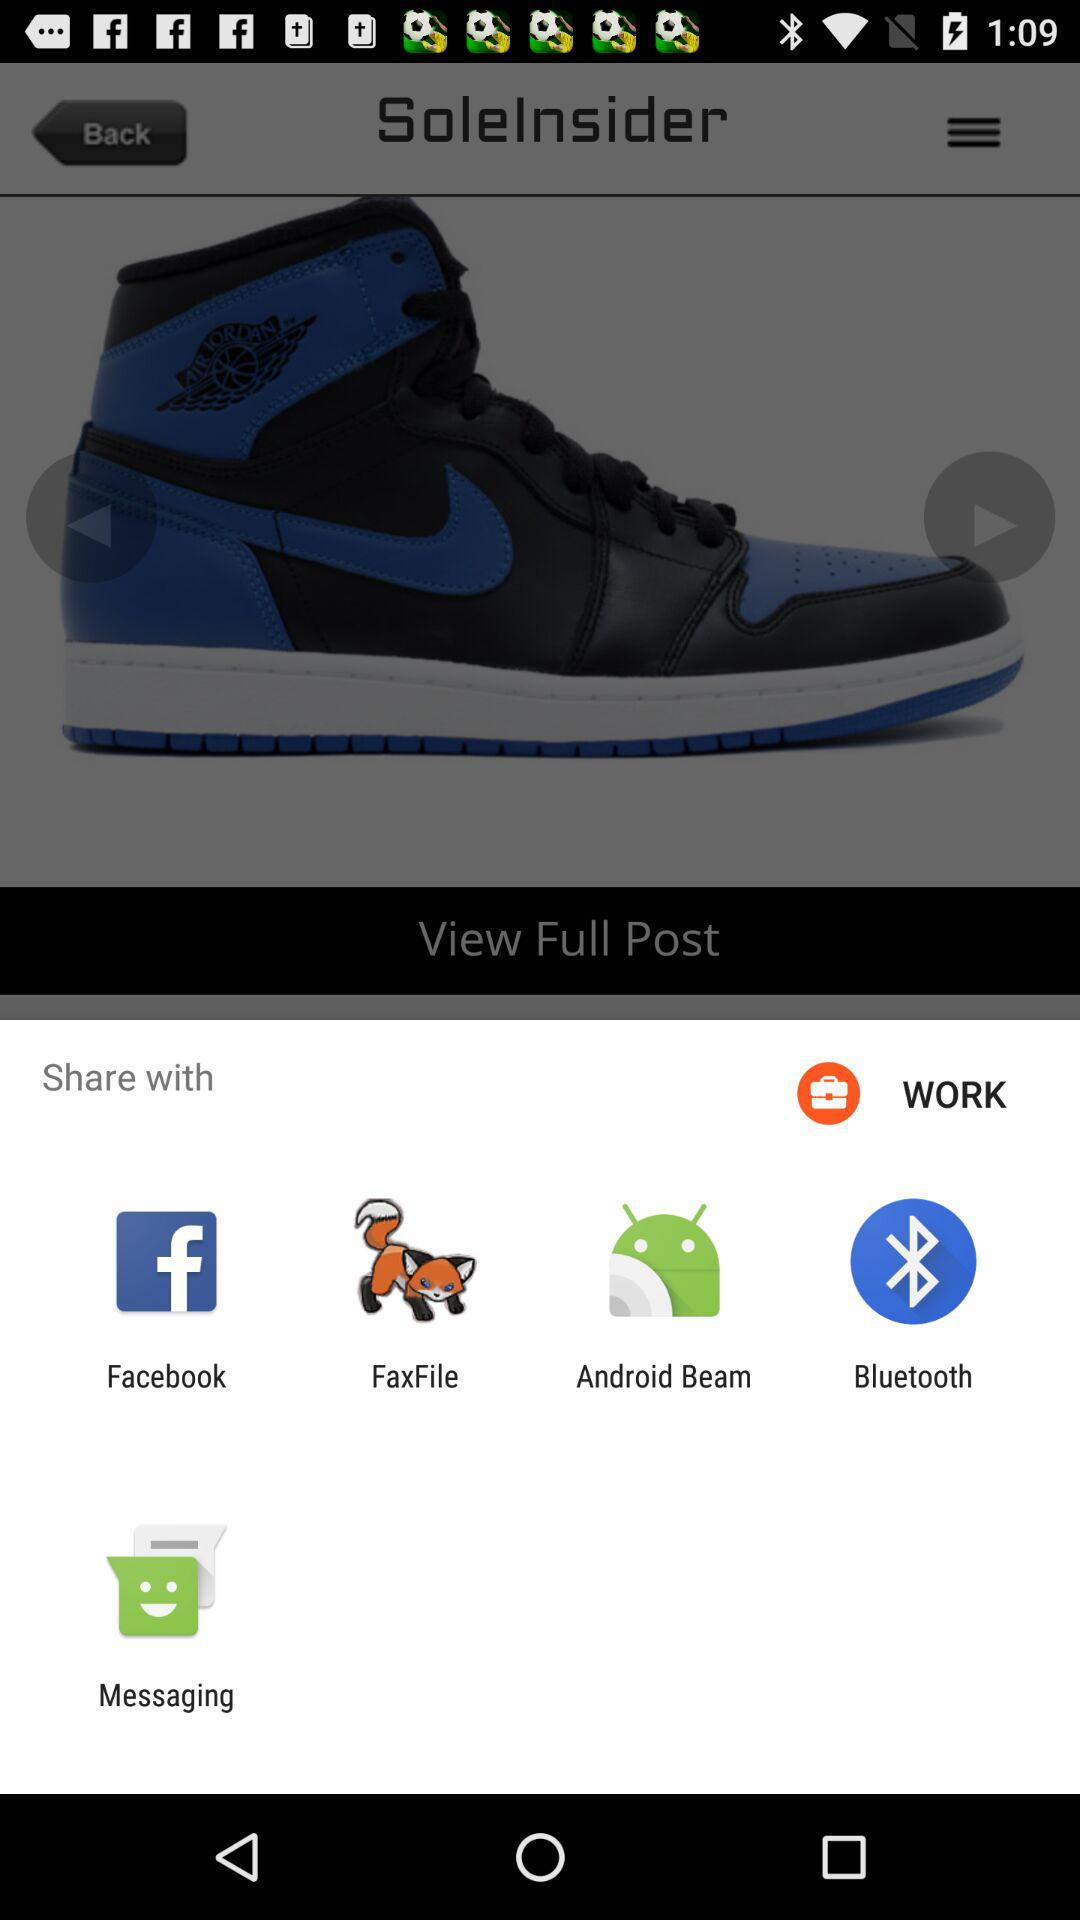How much are the shoes?
When the provided information is insufficient, respond with <no answer>. <no answer> 